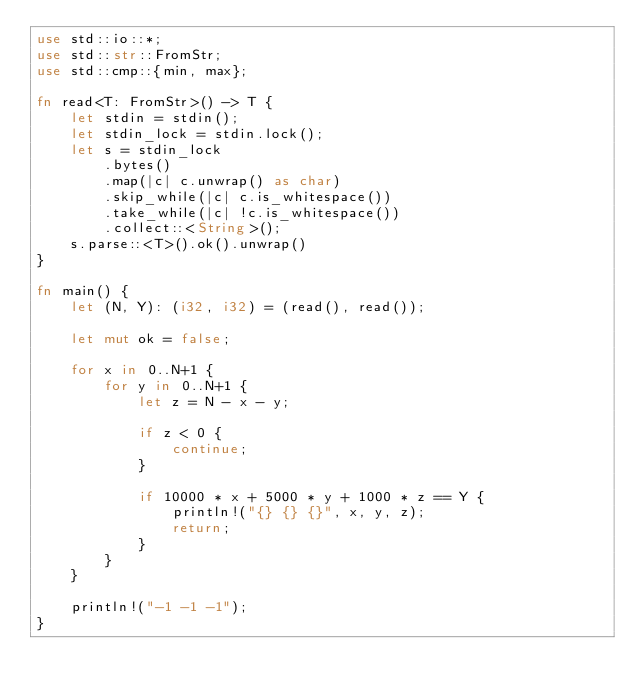<code> <loc_0><loc_0><loc_500><loc_500><_Rust_>use std::io::*;
use std::str::FromStr;
use std::cmp::{min, max};

fn read<T: FromStr>() -> T {
    let stdin = stdin();
    let stdin_lock = stdin.lock();
    let s = stdin_lock
        .bytes()
        .map(|c| c.unwrap() as char)
        .skip_while(|c| c.is_whitespace())
        .take_while(|c| !c.is_whitespace())
        .collect::<String>();
    s.parse::<T>().ok().unwrap()
}

fn main() {
    let (N, Y): (i32, i32) = (read(), read());

    let mut ok = false;

    for x in 0..N+1 {
        for y in 0..N+1 {
            let z = N - x - y;

            if z < 0 {
                continue;
            }

            if 10000 * x + 5000 * y + 1000 * z == Y {
                println!("{} {} {}", x, y, z);
                return;
            }
        }
    }

    println!("-1 -1 -1");
}</code> 